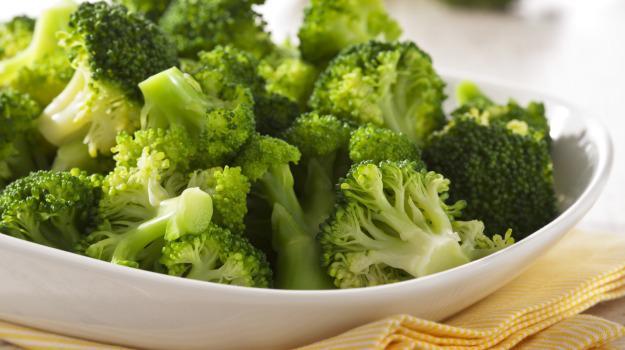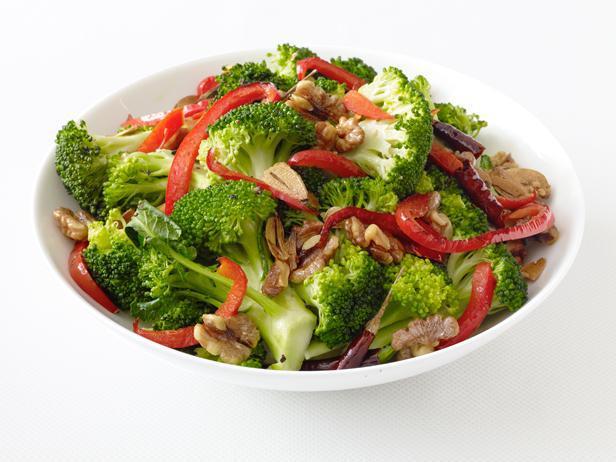The first image is the image on the left, the second image is the image on the right. For the images shown, is this caption "Everything is in white bowls." true? Answer yes or no. Yes. The first image is the image on the left, the second image is the image on the right. For the images displayed, is the sentence "Two parallel sticks are over a round bowl containing broccoli florets in one image." factually correct? Answer yes or no. No. 